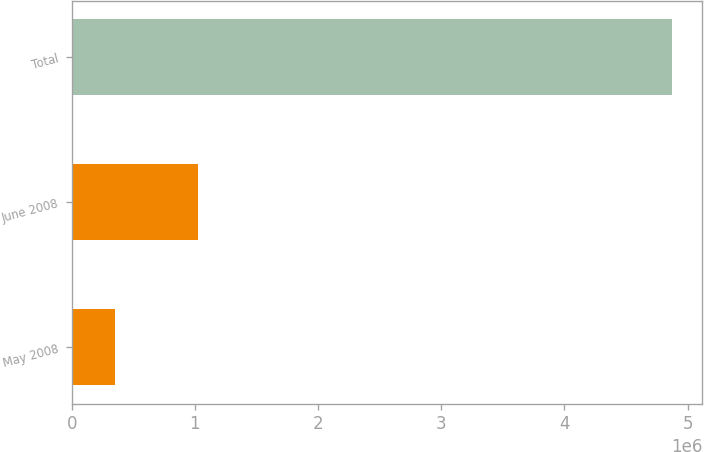Convert chart to OTSL. <chart><loc_0><loc_0><loc_500><loc_500><bar_chart><fcel>May 2008<fcel>June 2008<fcel>Total<nl><fcel>354600<fcel>1.0285e+06<fcel>4.87562e+06<nl></chart> 